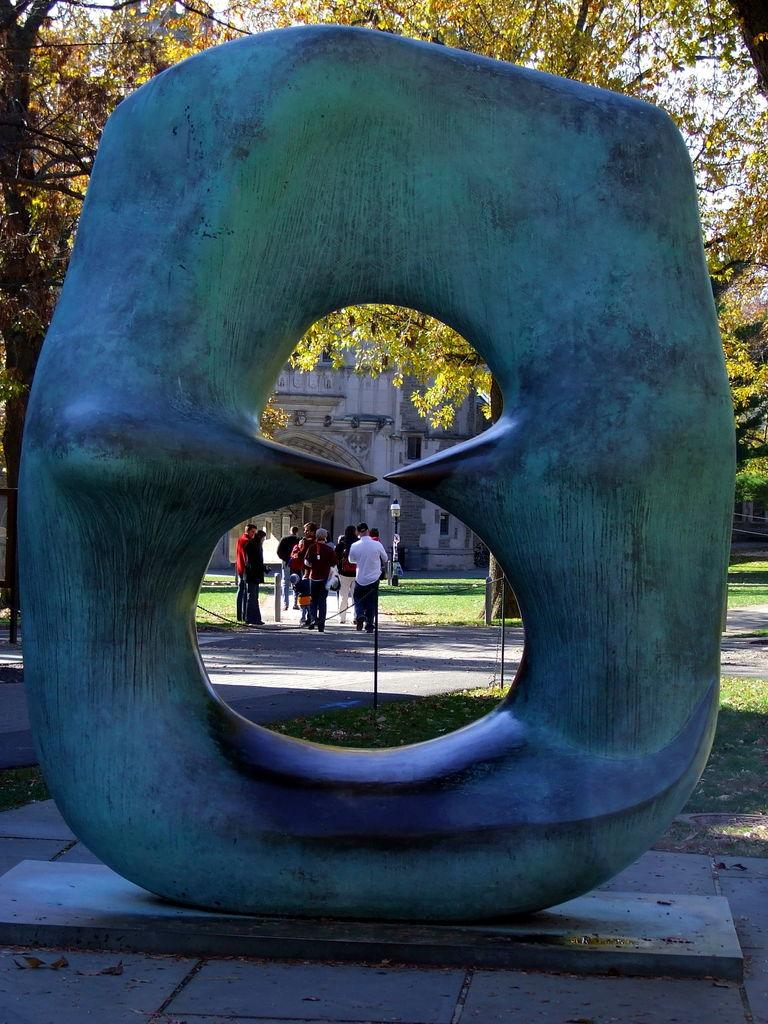What is the main subject in the middle of the image? There is a statue in the middle of the image. What can be seen in the background of the image? There are people and a building visible in the background of the image. What type of vegetation is present in the image? Trees are present in the image, and grass is present on the ground. What type of cable can be seen hanging from the tree in the image? There is no cable present in the image, nor is there a tree with a cable hanging from it. 